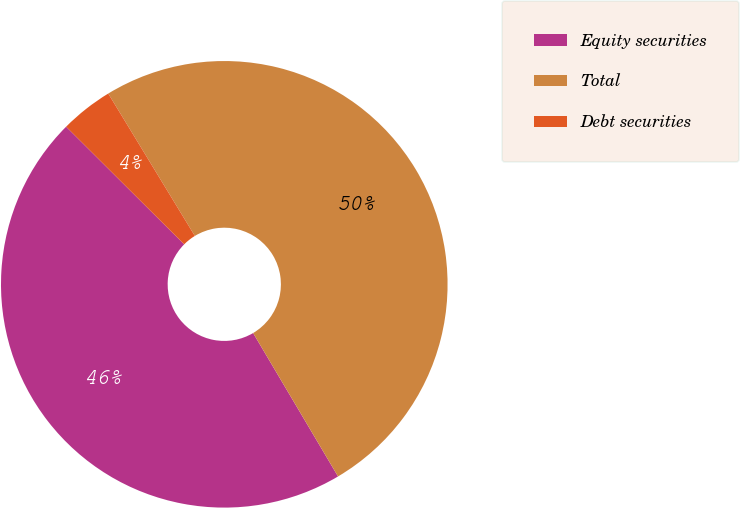Convert chart. <chart><loc_0><loc_0><loc_500><loc_500><pie_chart><fcel>Equity securities<fcel>Total<fcel>Debt securities<nl><fcel>45.98%<fcel>50.19%<fcel>3.83%<nl></chart> 